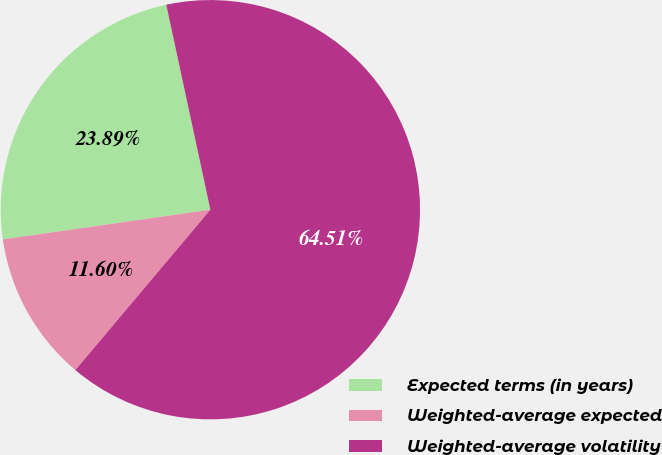Convert chart to OTSL. <chart><loc_0><loc_0><loc_500><loc_500><pie_chart><fcel>Expected terms (in years)<fcel>Weighted-average expected<fcel>Weighted-average volatility<nl><fcel>23.89%<fcel>11.6%<fcel>64.51%<nl></chart> 